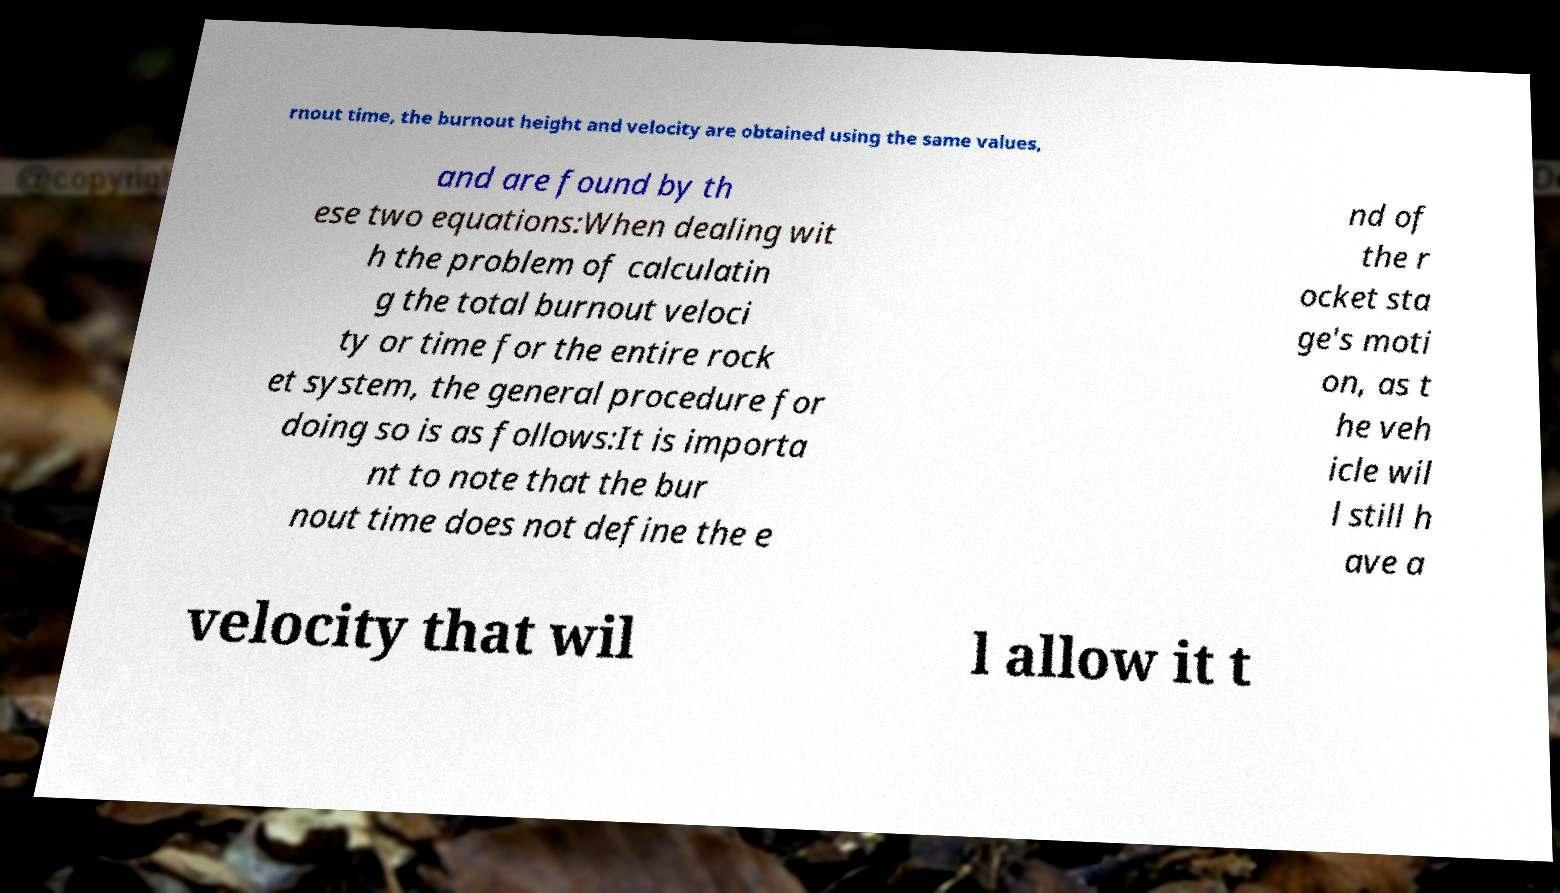I need the written content from this picture converted into text. Can you do that? rnout time, the burnout height and velocity are obtained using the same values, and are found by th ese two equations:When dealing wit h the problem of calculatin g the total burnout veloci ty or time for the entire rock et system, the general procedure for doing so is as follows:It is importa nt to note that the bur nout time does not define the e nd of the r ocket sta ge's moti on, as t he veh icle wil l still h ave a velocity that wil l allow it t 